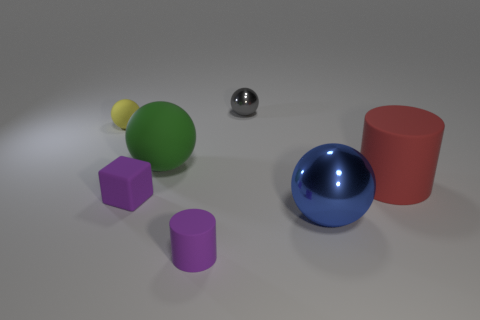Add 1 big blue rubber cylinders. How many objects exist? 8 Subtract all yellow matte balls. How many balls are left? 3 Add 6 big green rubber balls. How many big green rubber balls are left? 7 Add 6 big red things. How many big red things exist? 7 Subtract all purple cylinders. How many cylinders are left? 1 Subtract 0 gray blocks. How many objects are left? 7 Subtract all cylinders. How many objects are left? 5 Subtract 1 cylinders. How many cylinders are left? 1 Subtract all brown balls. Subtract all brown blocks. How many balls are left? 4 Subtract all gray cylinders. How many green blocks are left? 0 